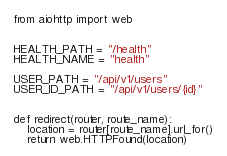<code> <loc_0><loc_0><loc_500><loc_500><_Python_>from aiohttp import web


HEALTH_PATH = "/health"
HEALTH_NAME = "health"

USER_PATH = "/api/v1/users"
USER_ID_PATH = "/api/v1/users/{id}"


def redirect(router, route_name):
    location = router[route_name].url_for()
    return web.HTTPFound(location)
</code> 